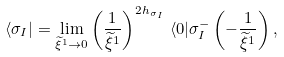Convert formula to latex. <formula><loc_0><loc_0><loc_500><loc_500>\langle \sigma _ { I } | = \lim _ { \widetilde { \xi } ^ { 1 } \rightarrow 0 } \left ( \frac { 1 } { \widetilde { \xi } ^ { 1 } } \right ) ^ { 2 h _ { \sigma _ { I } } } \, \langle 0 | \sigma ^ { - } _ { I } \left ( - \frac { 1 } { \widetilde { \xi } ^ { 1 } } \right ) ,</formula> 